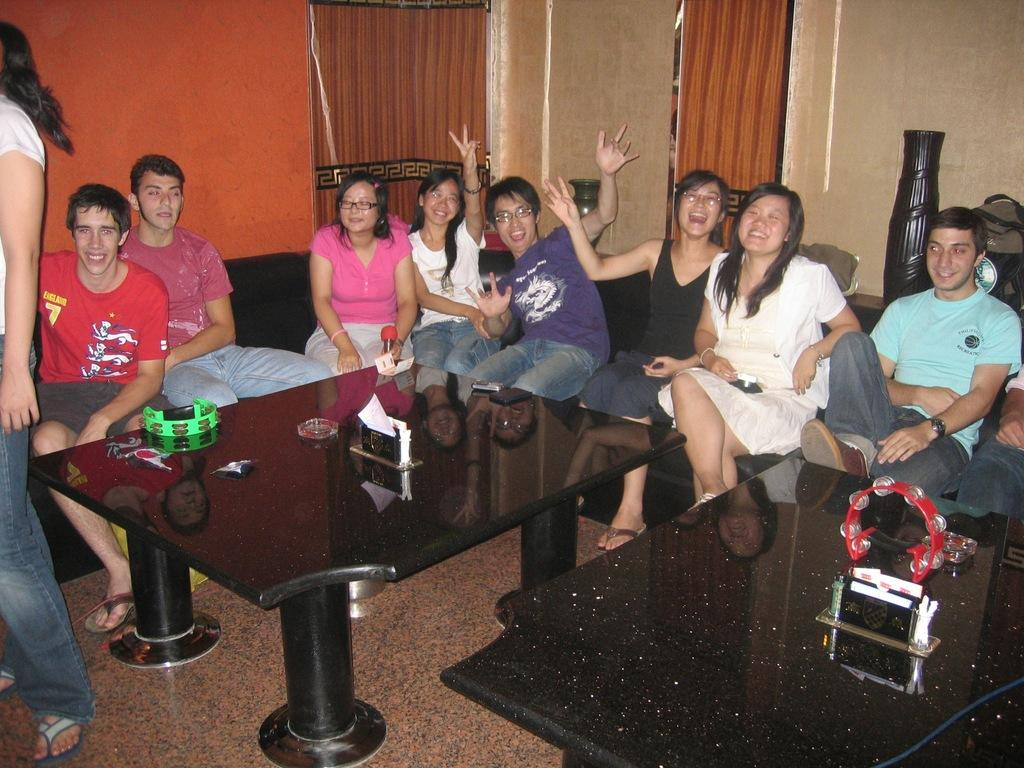What are the people in the image doing? There is a group of people sitting on a sofa in the image. What can be seen in front of the group? There are two black tables in front of the group. What is on the tables? There are objects on the tables. Is there anyone else in the image besides the group on the sofa? Yes, there is a person standing in the left corner of the image. Can you see any quicksand in the image? No, there is no quicksand present in the image. What type of canvas is being used by the person standing in the left corner? There is no canvas visible in the image; the person is standing in the corner without any apparent activity involving a canvas. 